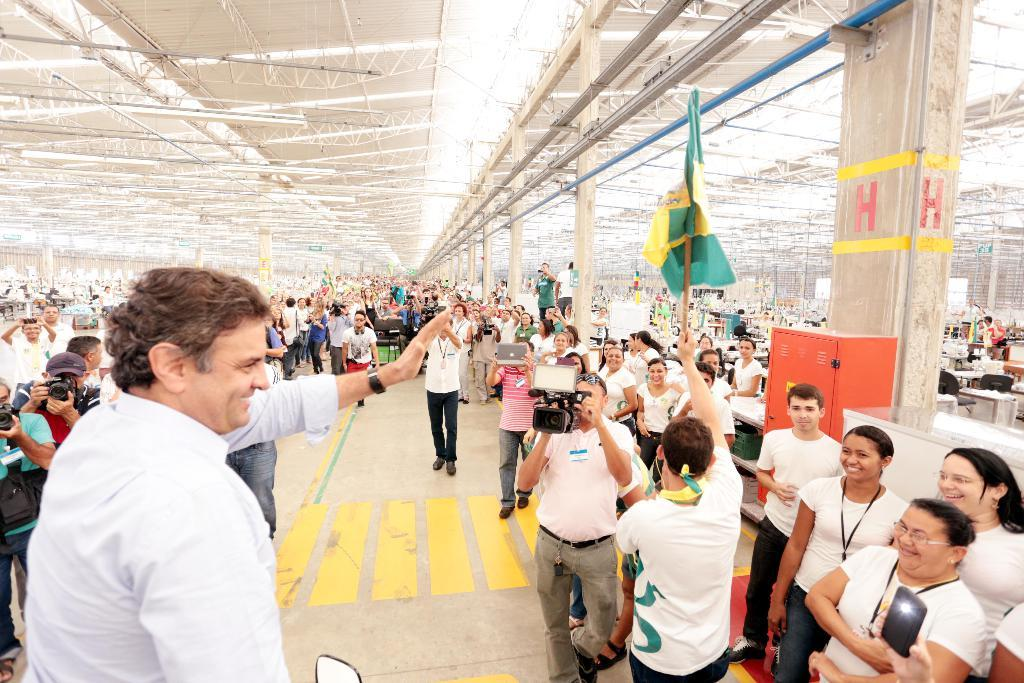How many people are in the image? There is a group of people in the image. What are some of the people in the group doing? Some people in the group are holding cameras. What architectural features can be seen in the image? There are pillars visible in the image. What type of structure is present in the image? There is a shed in the image. What color is the bedroom in the image? There is no bedroom present in the image. How does the sneeze affect the group of people in the image? There is no sneeze depicted in the image, so it cannot affect the group of people. 